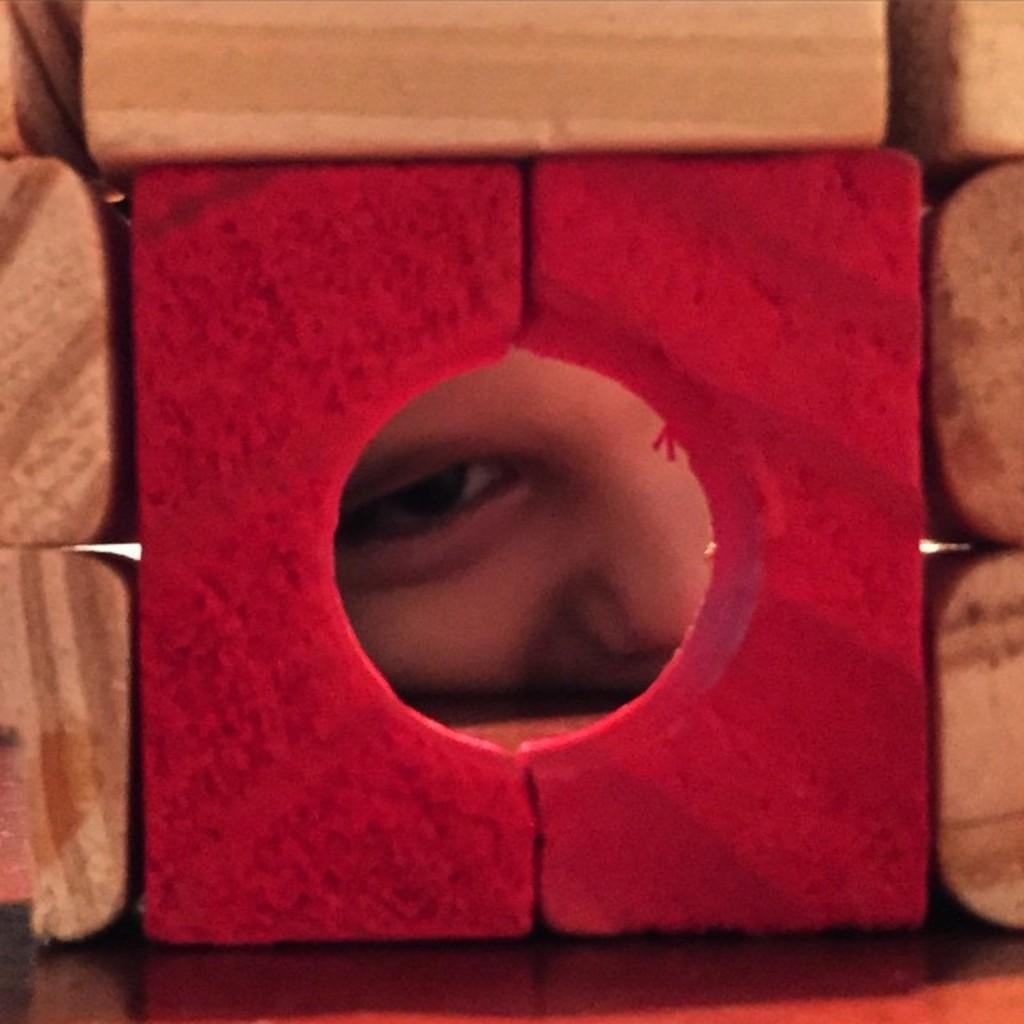What is the main feature in the center of the image? There is a block hole in the center of the image. What can be seen through the block hole? A person's eye is visible through the block hole. What are the other blocks in the image made of? The other blocks are made of the same material as the block with the hole. What type of paper can be seen being folded in the image? There is no paper or folding activity present in the image. 